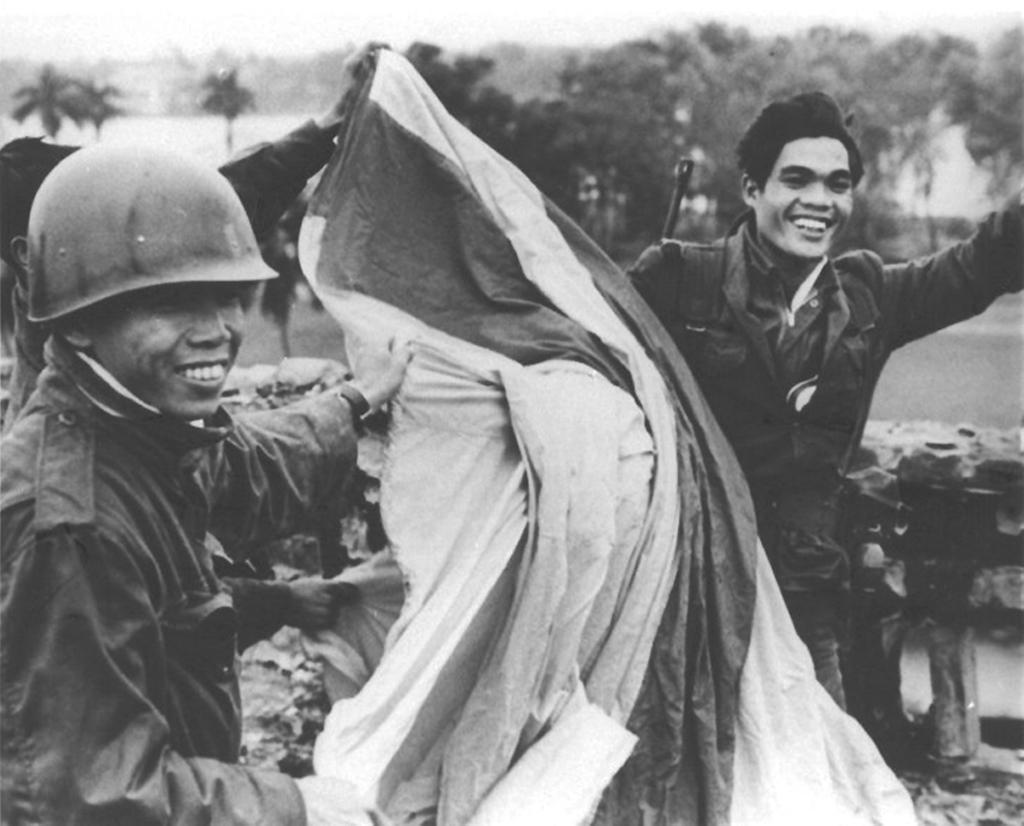How many people are in the image? There are two people in the image. What is the facial expression of the people in the image? Both people are smiling. What type of natural environment can be seen in the image? There are trees visible in the image. What is the person on the left side of the image wearing? The person on the left side of the image is wearing a helmet. What type of juice is being served in the vase in the image? There is no juice or vase present in the image. 